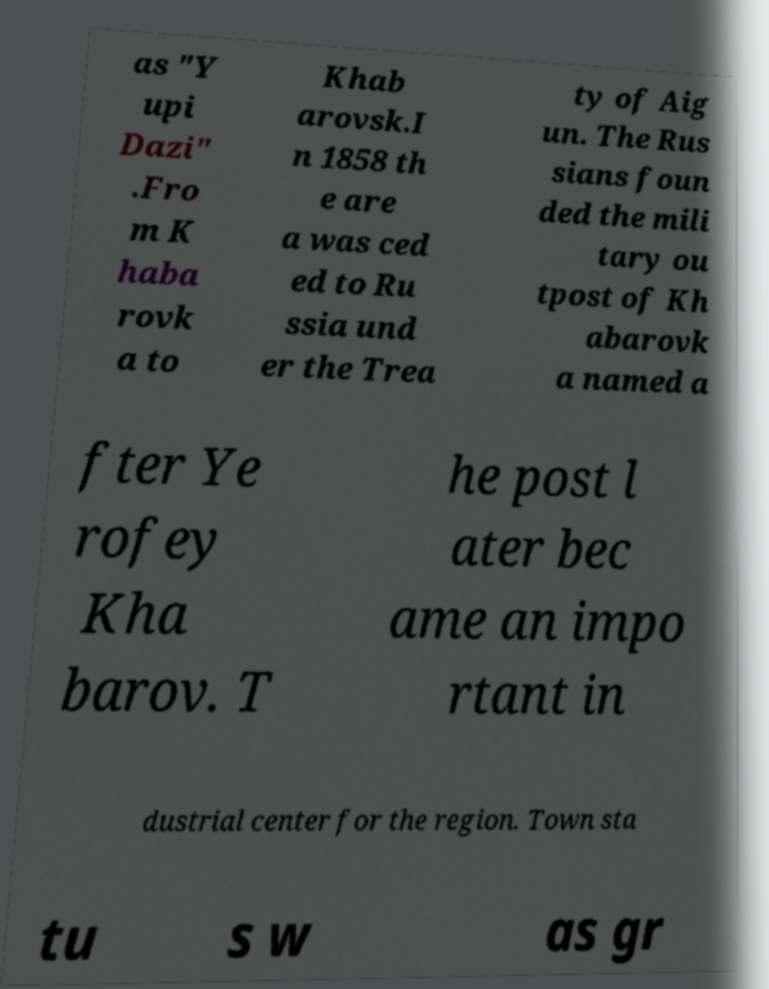Please read and relay the text visible in this image. What does it say? as "Y upi Dazi" .Fro m K haba rovk a to Khab arovsk.I n 1858 th e are a was ced ed to Ru ssia und er the Trea ty of Aig un. The Rus sians foun ded the mili tary ou tpost of Kh abarovk a named a fter Ye rofey Kha barov. T he post l ater bec ame an impo rtant in dustrial center for the region. Town sta tu s w as gr 